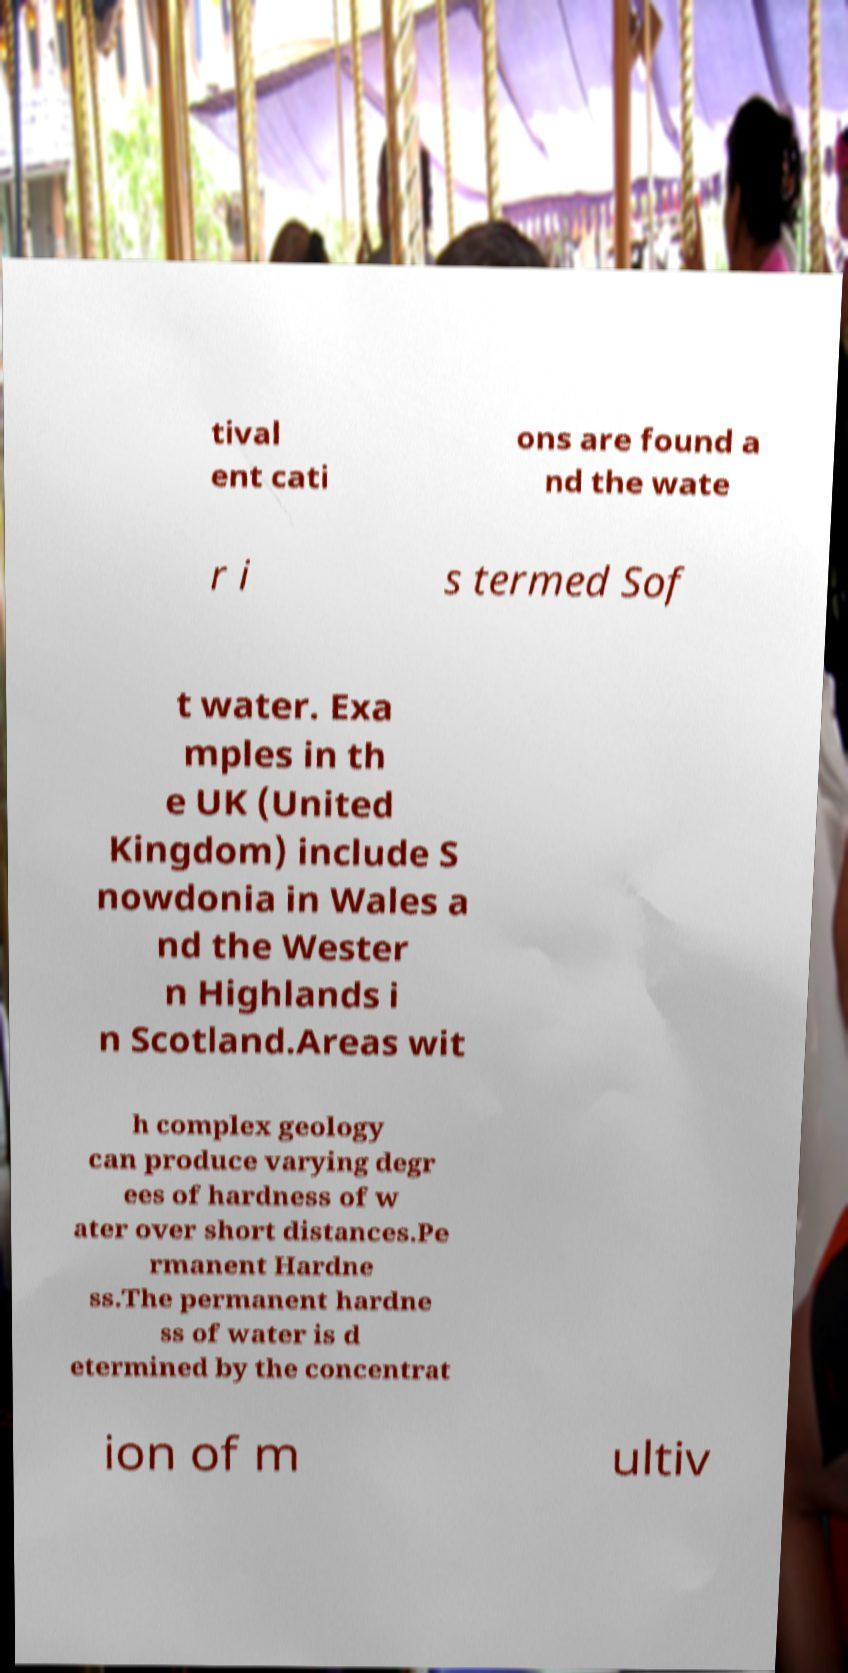Please identify and transcribe the text found in this image. tival ent cati ons are found a nd the wate r i s termed Sof t water. Exa mples in th e UK (United Kingdom) include S nowdonia in Wales a nd the Wester n Highlands i n Scotland.Areas wit h complex geology can produce varying degr ees of hardness of w ater over short distances.Pe rmanent Hardne ss.The permanent hardne ss of water is d etermined by the concentrat ion of m ultiv 